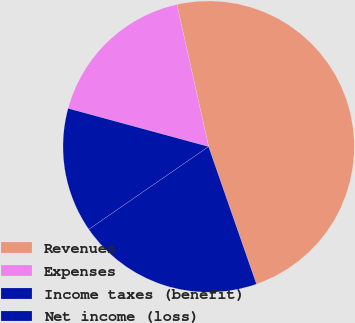Convert chart to OTSL. <chart><loc_0><loc_0><loc_500><loc_500><pie_chart><fcel>Revenues<fcel>Expenses<fcel>Income taxes (benefit)<fcel>Net income (loss)<nl><fcel>48.16%<fcel>17.28%<fcel>13.85%<fcel>20.71%<nl></chart> 